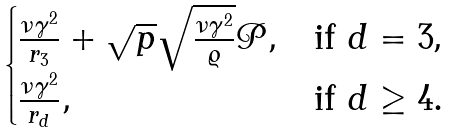<formula> <loc_0><loc_0><loc_500><loc_500>\begin{cases} \frac { \nu \gamma ^ { 2 } } { r _ { 3 } } + \sqrt { p } \sqrt { \frac { \nu \gamma ^ { 2 } } { \varrho } } \mathcal { P } , & \text {if $d=3$,} \\ \frac { \nu \gamma ^ { 2 } } { r _ { d } } , & \text {if $d\geq 4$.} \end{cases}</formula> 